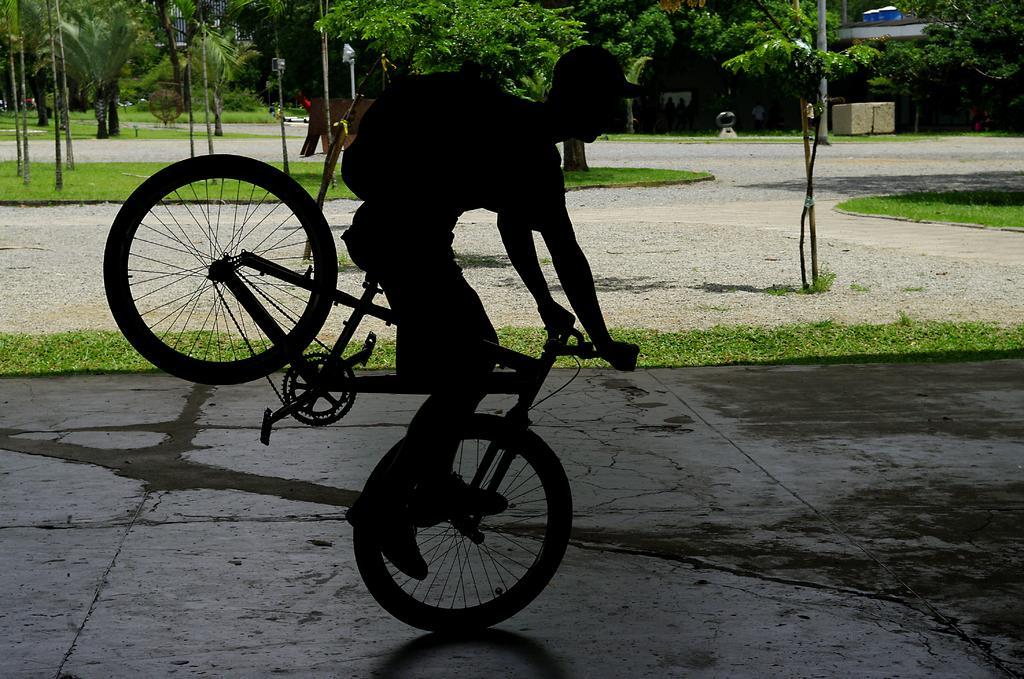Can you describe this image briefly? In this image I can see a person riding the bicycle. In the background there are trees. 